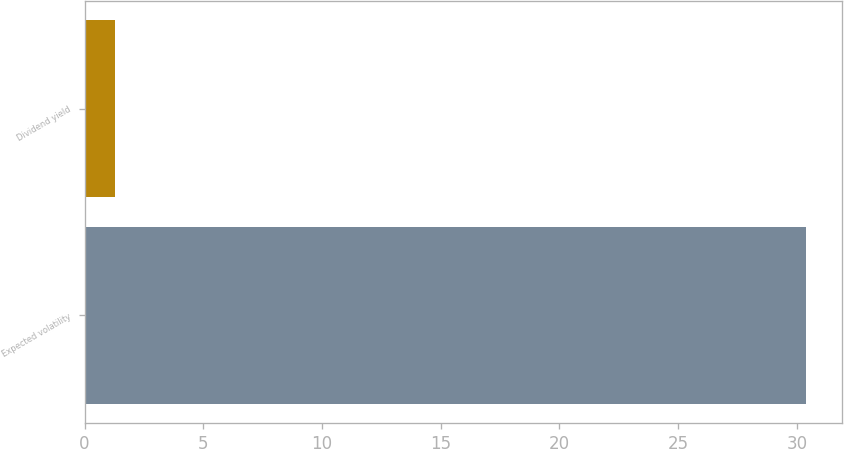Convert chart to OTSL. <chart><loc_0><loc_0><loc_500><loc_500><bar_chart><fcel>Expected volatility<fcel>Dividend yield<nl><fcel>30.4<fcel>1.3<nl></chart> 